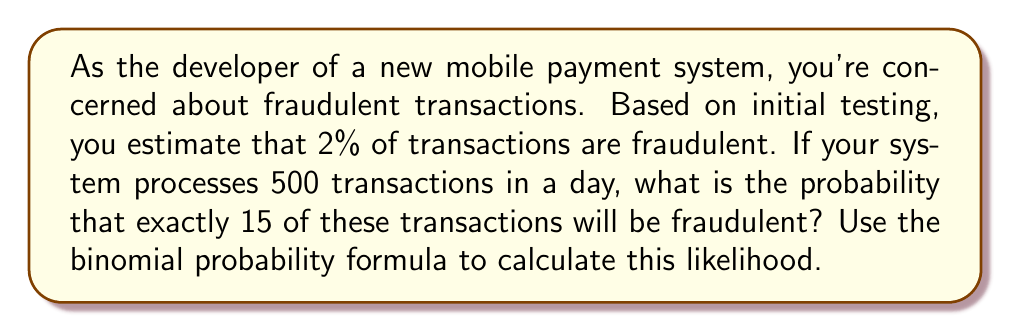Show me your answer to this math problem. To solve this problem, we'll use the binomial probability formula:

$$ P(X = k) = \binom{n}{k} p^k (1-p)^{n-k} $$

Where:
- $n$ is the number of trials (total transactions)
- $k$ is the number of successes (fraudulent transactions)
- $p$ is the probability of success on each trial (probability of a fraudulent transaction)

Given:
- $n = 500$ (total transactions in a day)
- $k = 15$ (number of fraudulent transactions we're interested in)
- $p = 0.02$ (2% chance of a fraudulent transaction)

Step 1: Calculate the binomial coefficient $\binom{n}{k}$
$$ \binom{500}{15} = \frac{500!}{15!(500-15)!} = 2.3247 \times 10^{26} $$

Step 2: Calculate $p^k$
$$ 0.02^{15} = 3.2768 \times 10^{-30} $$

Step 3: Calculate $(1-p)^{n-k}$
$$ 0.98^{485} = 0.0001038 $$

Step 4: Multiply all parts together
$$ P(X = 15) = 2.3247 \times 10^{26} \times 3.2768 \times 10^{-30} \times 0.0001038 = 0.0007916 $$

Therefore, the probability of exactly 15 fraudulent transactions out of 500 is approximately 0.0007916 or 0.07916%.
Answer: 0.0007916 